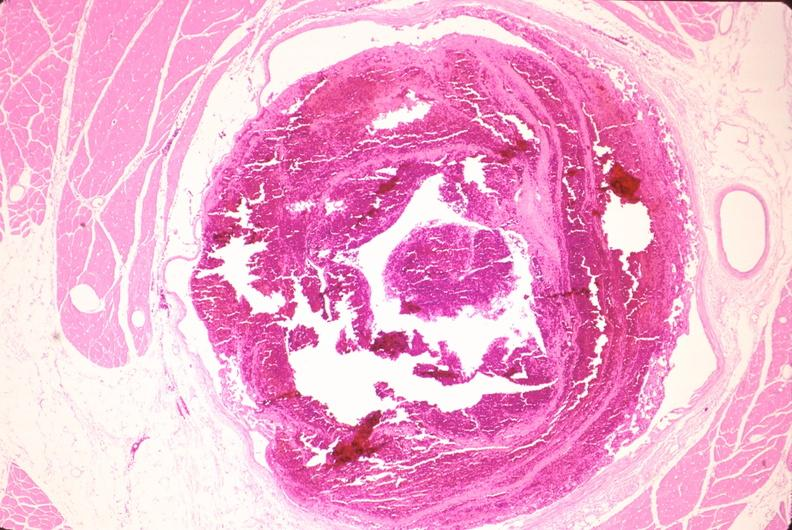what is present?
Answer the question using a single word or phrase. Vasculature 